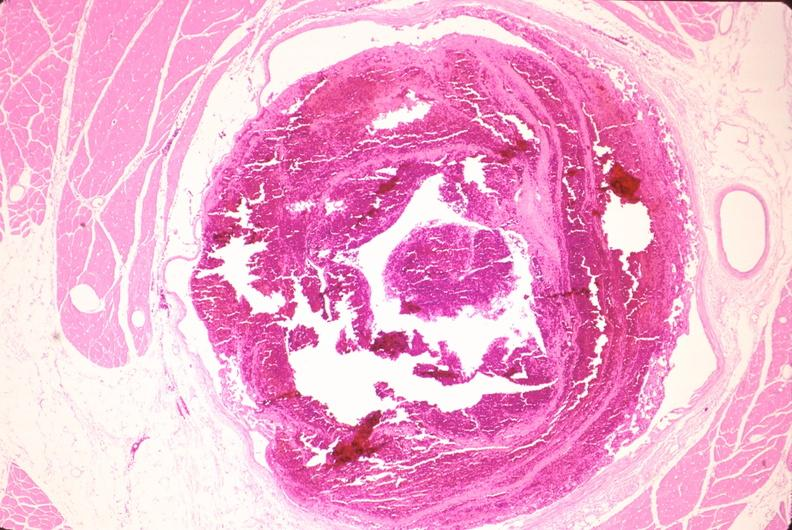what is present?
Answer the question using a single word or phrase. Vasculature 